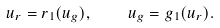<formula> <loc_0><loc_0><loc_500><loc_500>u _ { r } = r _ { 1 } ( u _ { g } ) , \quad u _ { g } = g _ { 1 } ( u _ { r } ) .</formula> 